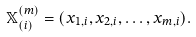<formula> <loc_0><loc_0><loc_500><loc_500>\mathbb { X } ^ { ( m ) } _ { ( i ) } = ( x _ { 1 , i } , x _ { 2 , i } , \dots , x _ { m , i } ) .</formula> 